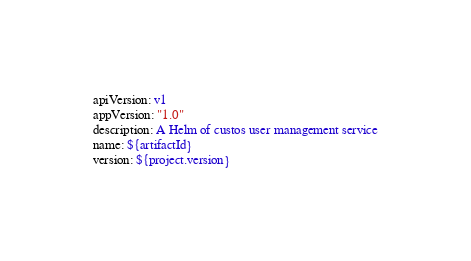<code> <loc_0><loc_0><loc_500><loc_500><_YAML_>apiVersion: v1
appVersion: "1.0"
description: A Helm of custos user management service
name: ${artifactId}
version: ${project.version}
</code> 